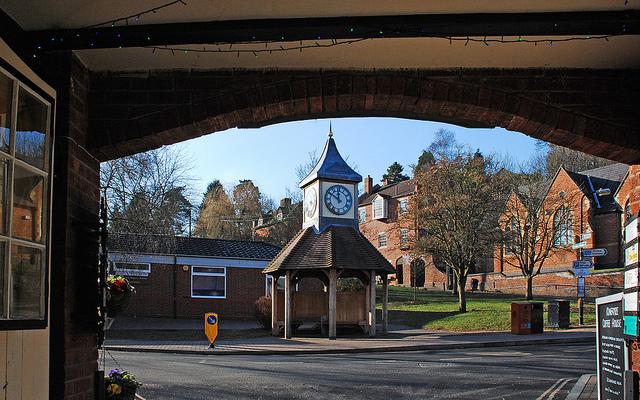Is this photo out of focus?
Give a very brief answer. No. What season is this?
Be succinct. Fall. What time is on the clock?
Keep it brief. 11:50. What kind of office is this?
Short answer required. Outside. How many clocks are visible?
Keep it brief. 2. Is there an image of a rainbow in the photo?
Give a very brief answer. No. 